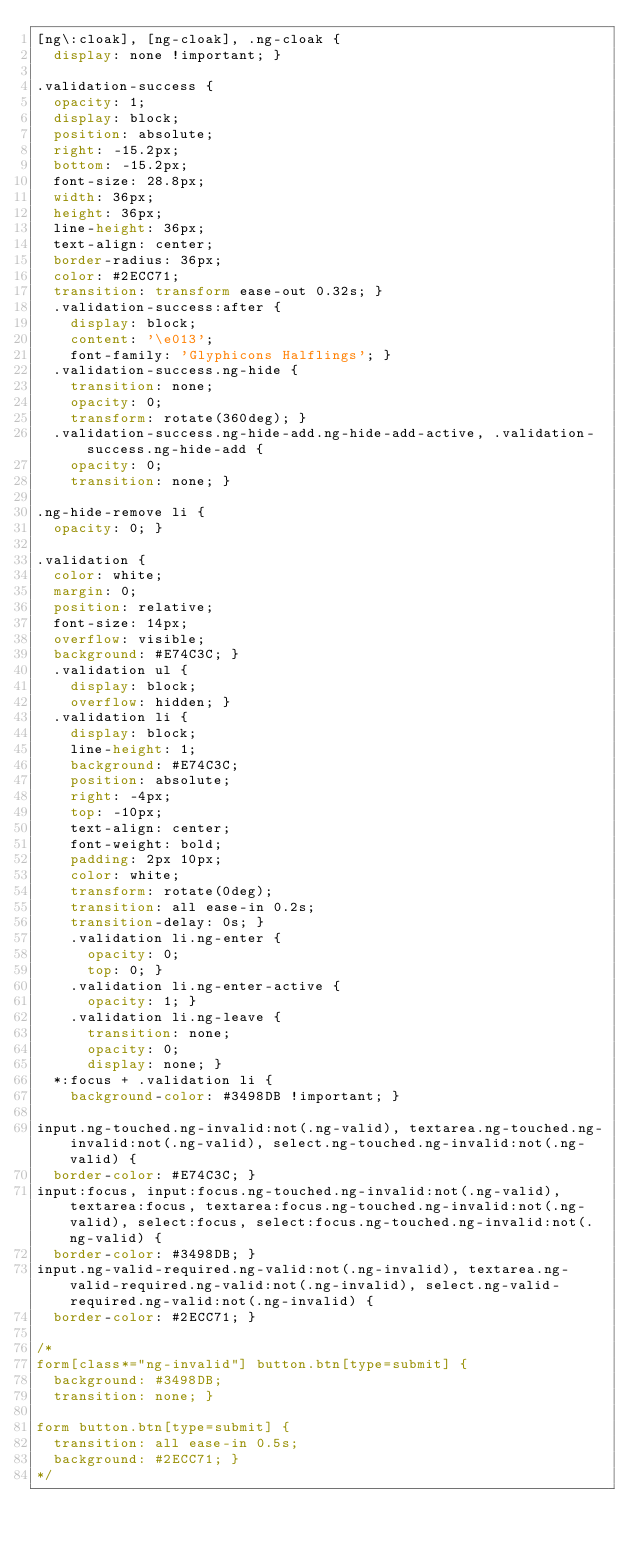Convert code to text. <code><loc_0><loc_0><loc_500><loc_500><_CSS_>[ng\:cloak], [ng-cloak], .ng-cloak {
  display: none !important; }

.validation-success {
  opacity: 1;
  display: block;
  position: absolute;
  right: -15.2px;
  bottom: -15.2px;
  font-size: 28.8px;
  width: 36px;
  height: 36px;
  line-height: 36px;
  text-align: center;
  border-radius: 36px;
  color: #2ECC71;
  transition: transform ease-out 0.32s; }
  .validation-success:after {
    display: block;
    content: '\e013';
    font-family: 'Glyphicons Halflings'; }
  .validation-success.ng-hide {
    transition: none;
    opacity: 0;
    transform: rotate(360deg); }
  .validation-success.ng-hide-add.ng-hide-add-active, .validation-success.ng-hide-add {
    opacity: 0;
    transition: none; }

.ng-hide-remove li {
  opacity: 0; }

.validation {
  color: white;
  margin: 0;
  position: relative;
  font-size: 14px;
  overflow: visible;
  background: #E74C3C; }
  .validation ul {
    display: block;
    overflow: hidden; }
  .validation li {
    display: block;
    line-height: 1;
    background: #E74C3C;
    position: absolute;
    right: -4px;
    top: -10px;
    text-align: center;
    font-weight: bold;
    padding: 2px 10px;
    color: white;
    transform: rotate(0deg);
    transition: all ease-in 0.2s;
    transition-delay: 0s; }
    .validation li.ng-enter {
      opacity: 0;
      top: 0; }
    .validation li.ng-enter-active {
      opacity: 1; }
    .validation li.ng-leave {
      transition: none;
      opacity: 0;
      display: none; }
  *:focus + .validation li {
    background-color: #3498DB !important; }

input.ng-touched.ng-invalid:not(.ng-valid), textarea.ng-touched.ng-invalid:not(.ng-valid), select.ng-touched.ng-invalid:not(.ng-valid) {
  border-color: #E74C3C; }
input:focus, input:focus.ng-touched.ng-invalid:not(.ng-valid), textarea:focus, textarea:focus.ng-touched.ng-invalid:not(.ng-valid), select:focus, select:focus.ng-touched.ng-invalid:not(.ng-valid) {
  border-color: #3498DB; }
input.ng-valid-required.ng-valid:not(.ng-invalid), textarea.ng-valid-required.ng-valid:not(.ng-invalid), select.ng-valid-required.ng-valid:not(.ng-invalid) {
  border-color: #2ECC71; }

/*
form[class*="ng-invalid"] button.btn[type=submit] {
  background: #3498DB;
  transition: none; }

form button.btn[type=submit] {
  transition: all ease-in 0.5s;
  background: #2ECC71; }
*/</code> 